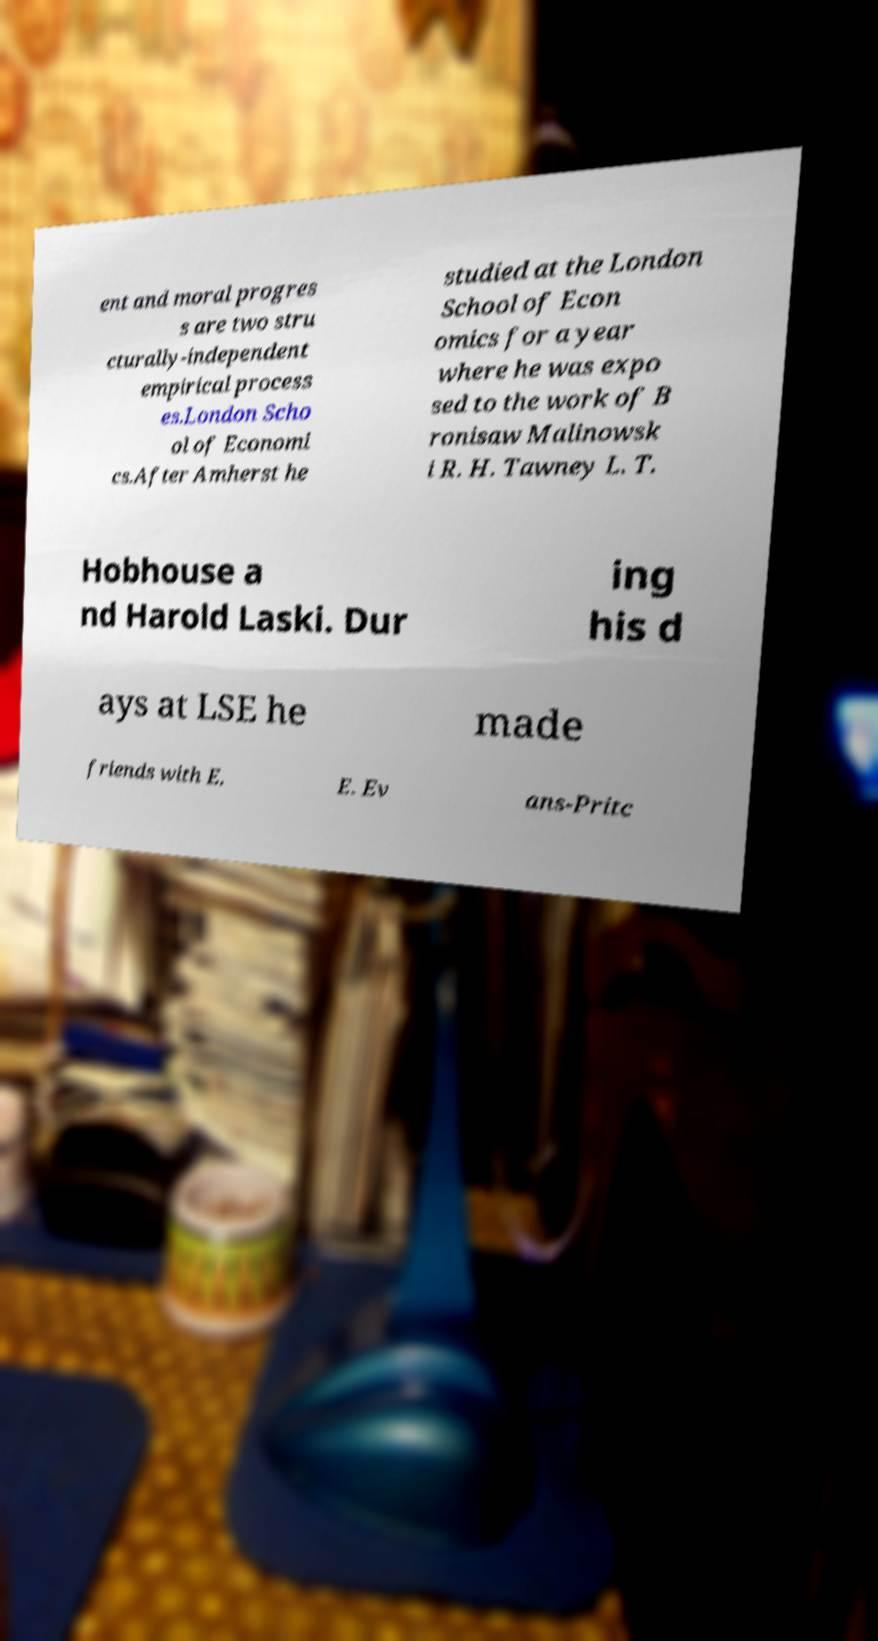What messages or text are displayed in this image? I need them in a readable, typed format. ent and moral progres s are two stru cturally-independent empirical process es.London Scho ol of Economi cs.After Amherst he studied at the London School of Econ omics for a year where he was expo sed to the work of B ronisaw Malinowsk i R. H. Tawney L. T. Hobhouse a nd Harold Laski. Dur ing his d ays at LSE he made friends with E. E. Ev ans-Pritc 